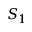Convert formula to latex. <formula><loc_0><loc_0><loc_500><loc_500>S _ { 1 }</formula> 